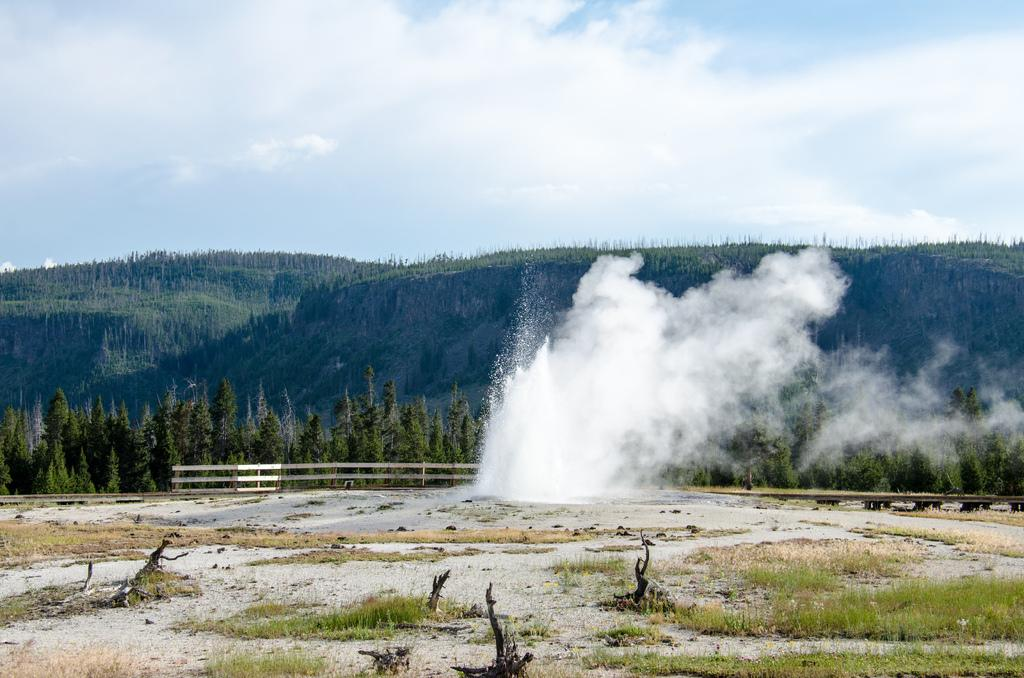What type of vegetation can be seen in the image? There is grass in the image. What structure is present in the image? There is a fence in the image. What other natural elements are visible in the image? There are trees in the image. What can be seen in the background of the image? The sky is visible in the background of the image. What is the condition of the sky in the image? There are clouds in the sky. What type of fuel can be seen in the image? There is no fuel present in the image. How many birds are perched on the fence in the image? There are no birds visible in the image. 